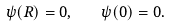Convert formula to latex. <formula><loc_0><loc_0><loc_500><loc_500>\psi ( R ) = 0 , \quad \psi ( 0 ) = 0 .</formula> 